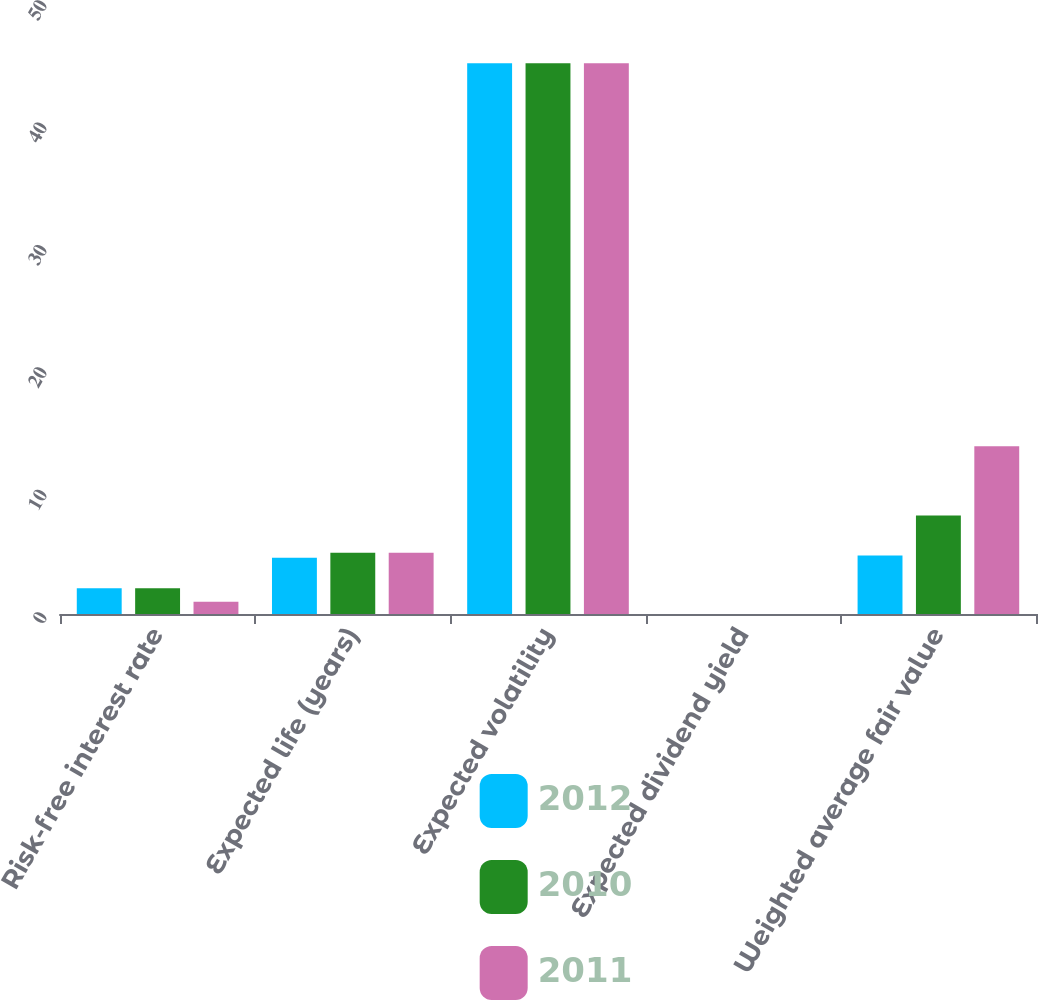Convert chart. <chart><loc_0><loc_0><loc_500><loc_500><stacked_bar_chart><ecel><fcel>Risk-free interest rate<fcel>Expected life (years)<fcel>Expected volatility<fcel>Expected dividend yield<fcel>Weighted average fair value<nl><fcel>2012<fcel>2.1<fcel>4.6<fcel>45<fcel>0<fcel>4.78<nl><fcel>2010<fcel>2.1<fcel>5<fcel>45<fcel>0<fcel>8.04<nl><fcel>2011<fcel>1<fcel>5<fcel>45<fcel>0<fcel>13.7<nl></chart> 